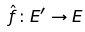Convert formula to latex. <formula><loc_0><loc_0><loc_500><loc_500>\hat { f } \colon E ^ { \prime } \rightarrow E</formula> 